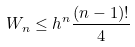Convert formula to latex. <formula><loc_0><loc_0><loc_500><loc_500>W _ { n } \leq h ^ { n } \frac { ( n - 1 ) ! } { 4 }</formula> 